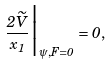Convert formula to latex. <formula><loc_0><loc_0><loc_500><loc_500>\frac { 2 \widetilde { V } } { x _ { 1 } } \Big | _ { \psi , F = 0 } = 0 ,</formula> 